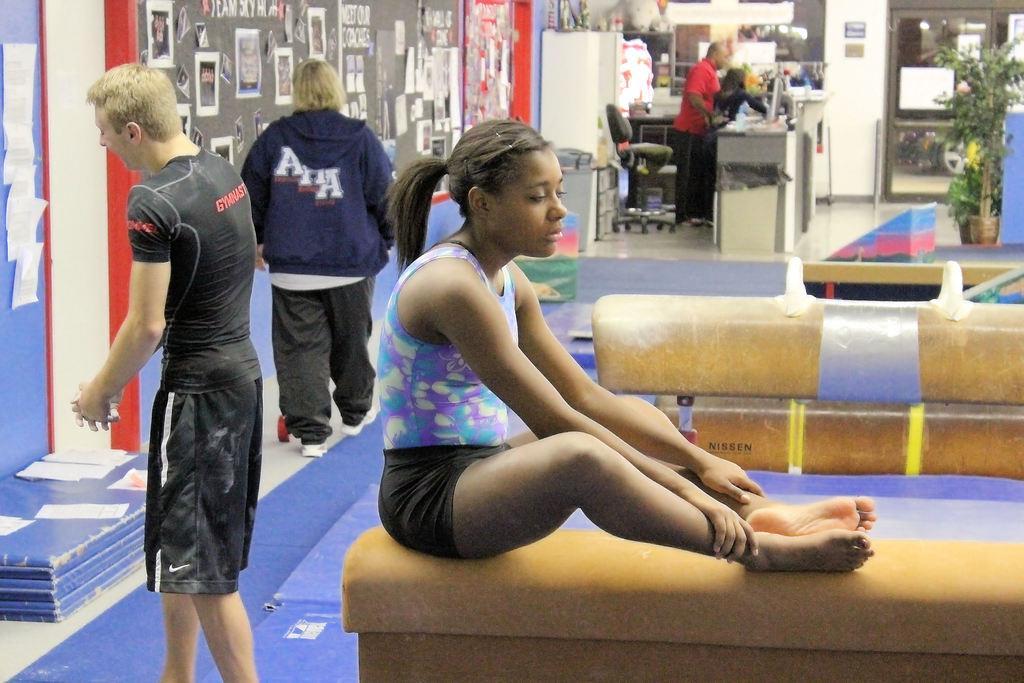Please provide a concise description of this image. In the picture we can see a exercise hall with a girl sitting on some exercise instrument and behind her we can see man standing and doing some exercises and one man is walking beside him and far away we can see a man standing near the desk and behind him we can see a chair and to the wall we can see some posters and near the desk we can see a door with glass and beside it we can see a plant. 